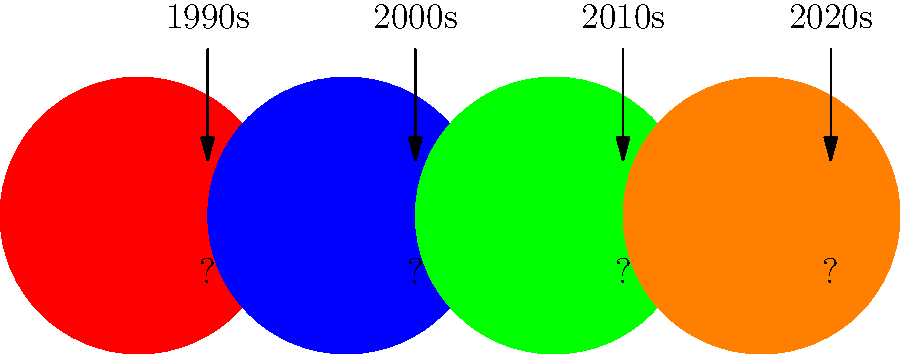Match Freddie Prinze Jr.'s iconic hairstyles to the corresponding decades of his career. Which hairstyle represents his look in the 2000s? To answer this question, let's break down Freddie Prinze Jr.'s career and hairstyles by decade:

1. 1990s: Freddie's career began in the late '90s with his breakout role in "I Know What You Did Last Summer" (1997). During this time, he sported a longer, floppy hairstyle typical of the '90s teen heartthrob look.

2. 2000s: This was arguably the peak of Freddie's mainstream popularity. He starred in movies like "She's All That" (1999), "Scooby-Doo" (2002), and "Scooby-Doo 2: Monsters Unleashed" (2004). His hairstyle during this period was shorter and more styled, often with spiky elements or a messy, tousled look.

3. 2010s: Freddie's on-screen appearances became less frequent, but he continued to work in voice acting. His hair during this decade was generally kept short and neat, reflecting a more mature look.

4. 2020s: In recent years, Freddie has maintained a relatively low profile in the entertainment industry. His current hairstyle tends to be shorter and more conservative, often with a bit of grey showing.

Based on this timeline, the hairstyle representing the 2000s would be the shorter, more styled look with spiky or tousled elements. This coincides with his most recognizable roles and peak of popularity.
Answer: Shorter, styled look with spiky or tousled elements 